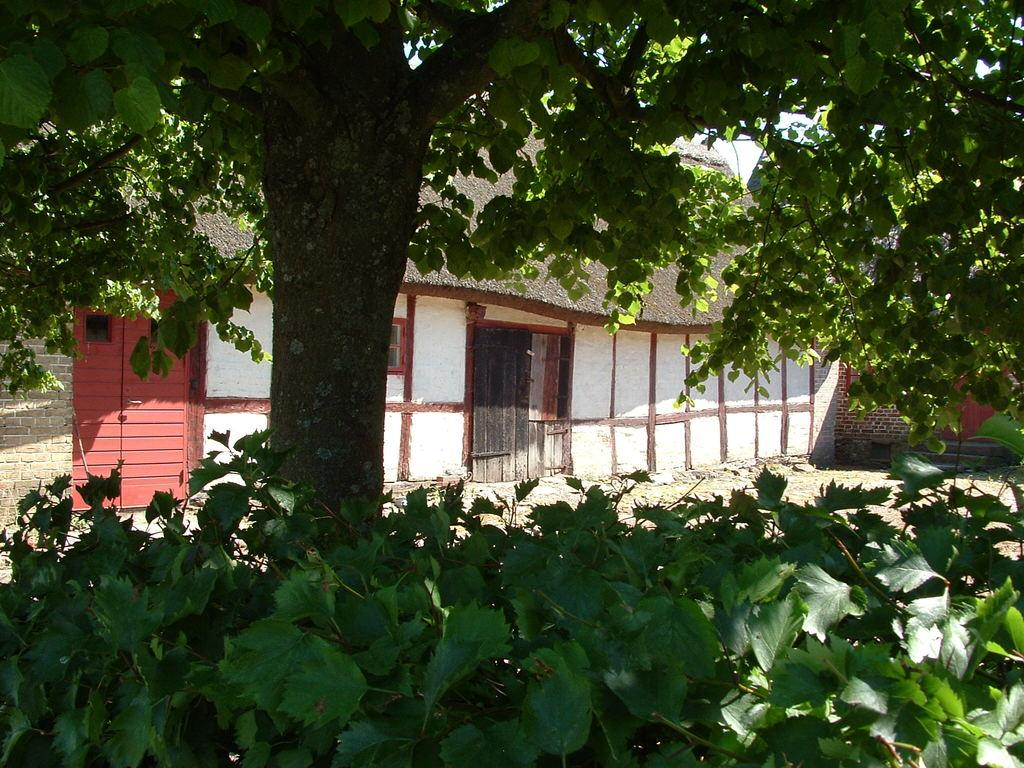What type of vegetation can be seen in the image? There are plants and a tree in the image. What type of structure is visible in the image? There is a house in the image. What is visible behind the house in the image? The sky is visible behind the house in the image. What type of yam is being stored in the pail next to the tree in the image? There is no pail or yam present in the image; it only features plants, a tree, a house, and the sky. 